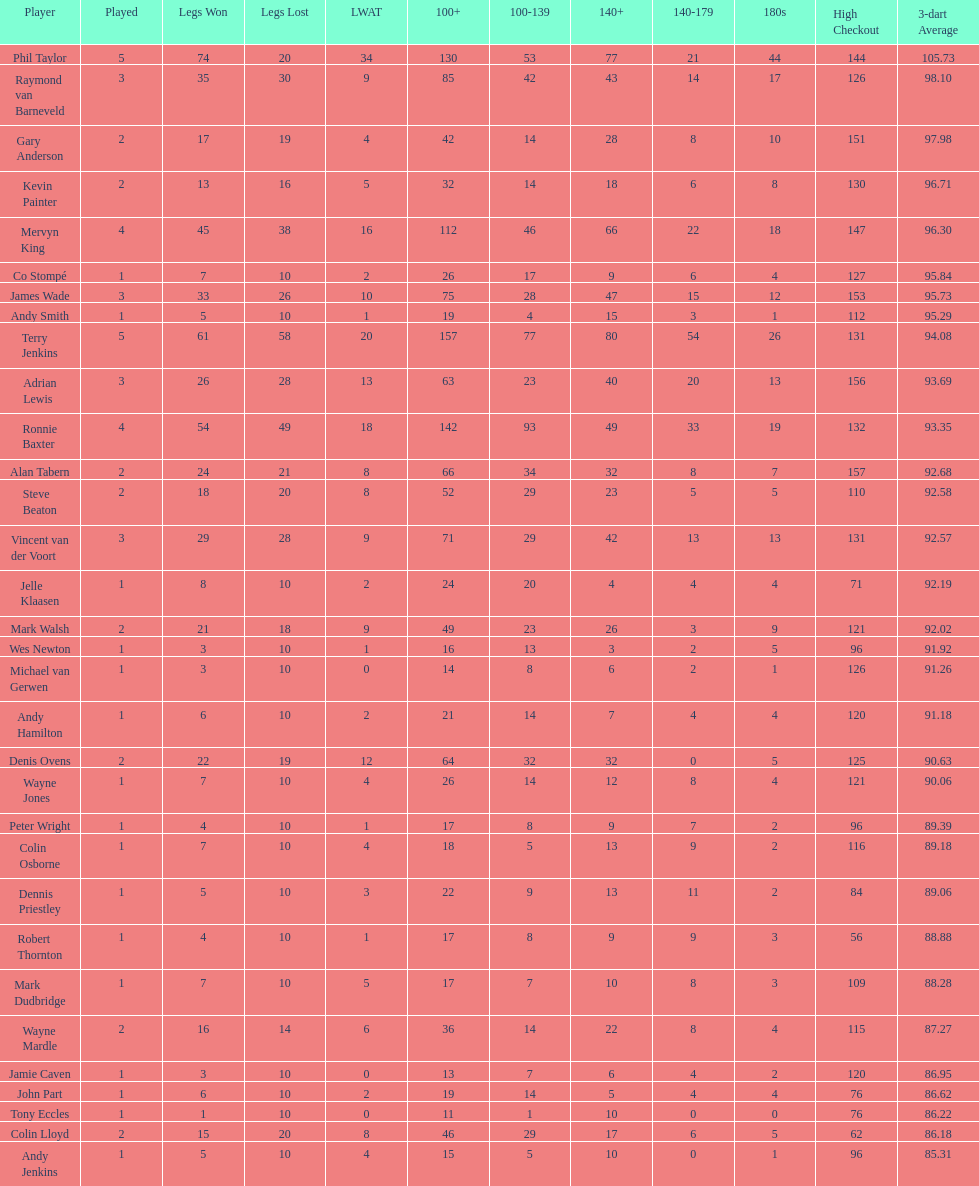Name all the individuals with a high checkout of 13 Terry Jenkins, Vincent van der Voort. 